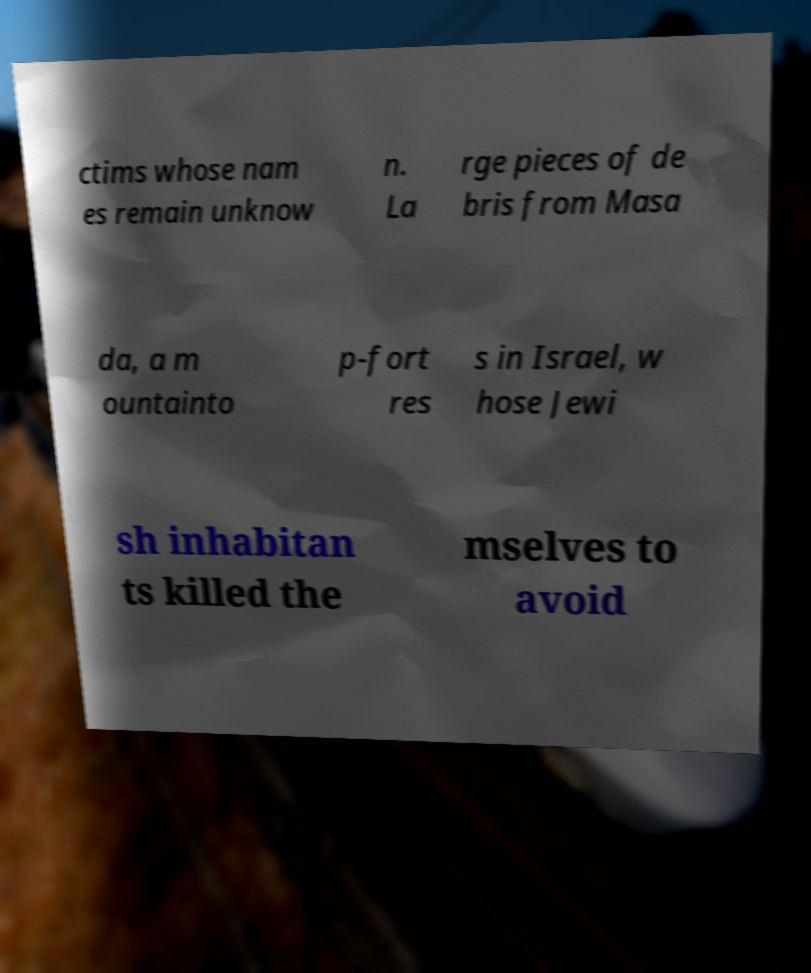Could you extract and type out the text from this image? ctims whose nam es remain unknow n. La rge pieces of de bris from Masa da, a m ountainto p-fort res s in Israel, w hose Jewi sh inhabitan ts killed the mselves to avoid 